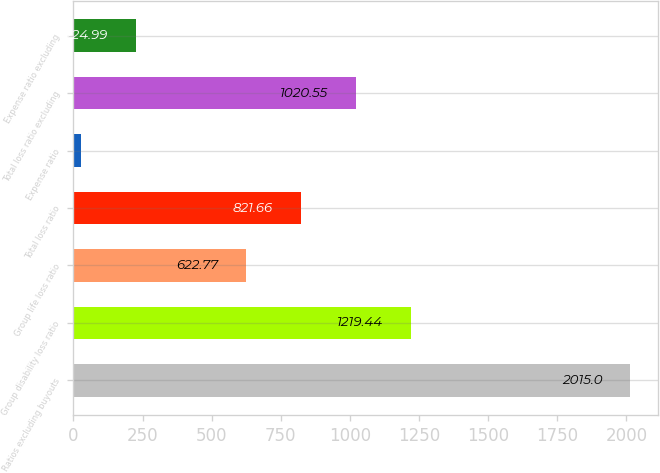Convert chart. <chart><loc_0><loc_0><loc_500><loc_500><bar_chart><fcel>Ratios excluding buyouts<fcel>Group disability loss ratio<fcel>Group life loss ratio<fcel>Total loss ratio<fcel>Expense ratio<fcel>Total loss ratio excluding<fcel>Expense ratio excluding<nl><fcel>2015<fcel>1219.44<fcel>622.77<fcel>821.66<fcel>26.1<fcel>1020.55<fcel>224.99<nl></chart> 